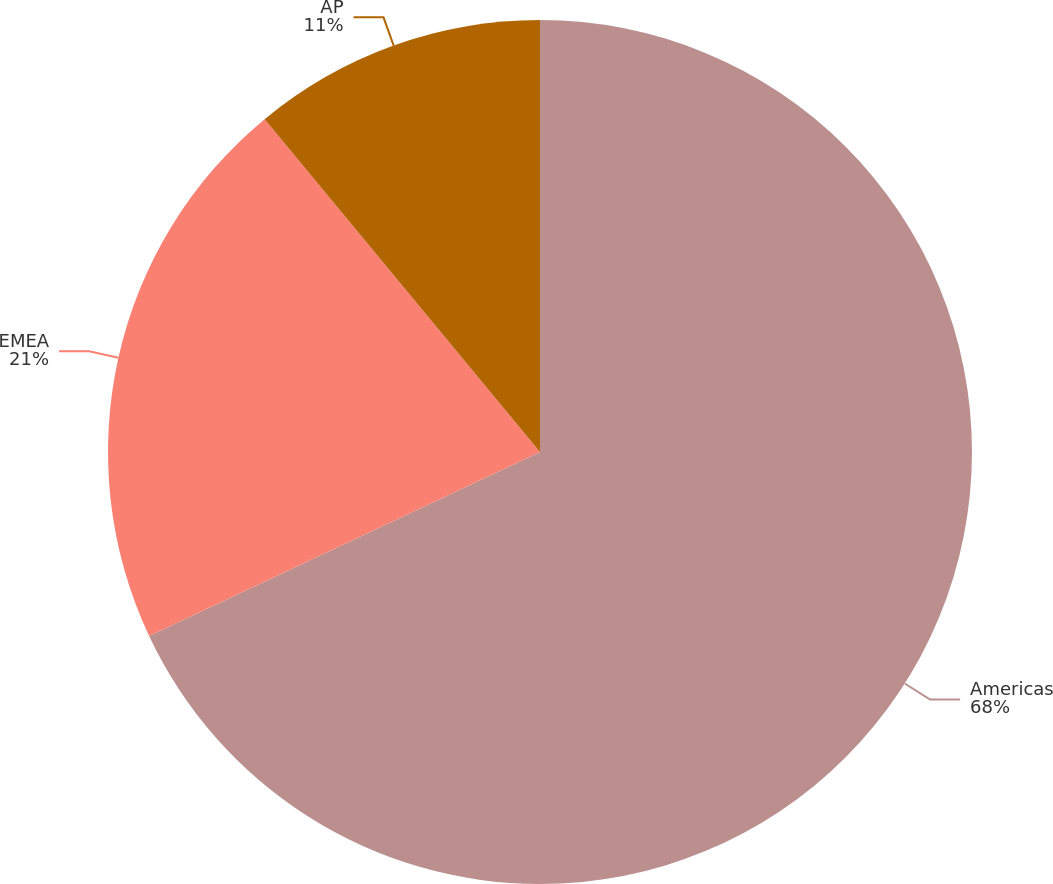Convert chart. <chart><loc_0><loc_0><loc_500><loc_500><pie_chart><fcel>Americas<fcel>EMEA<fcel>AP<nl><fcel>68.0%<fcel>21.0%<fcel>11.0%<nl></chart> 